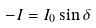Convert formula to latex. <formula><loc_0><loc_0><loc_500><loc_500>- I = I _ { 0 } \sin \delta</formula> 